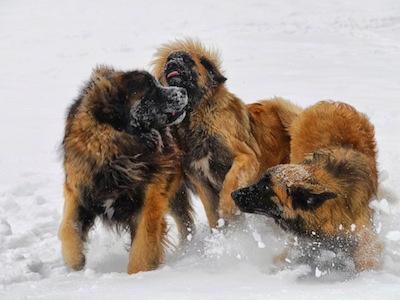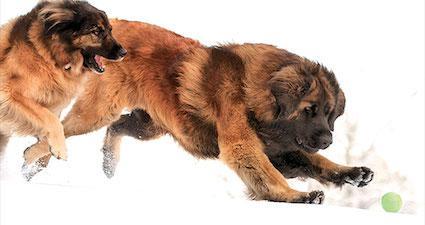The first image is the image on the left, the second image is the image on the right. Assess this claim about the two images: "There are two dogs outside in the grass in one of the images.". Correct or not? Answer yes or no. No. The first image is the image on the left, the second image is the image on the right. Analyze the images presented: Is the assertion "In one image, three dogs are shown together on a ground containing water in one of its states of matter." valid? Answer yes or no. Yes. 